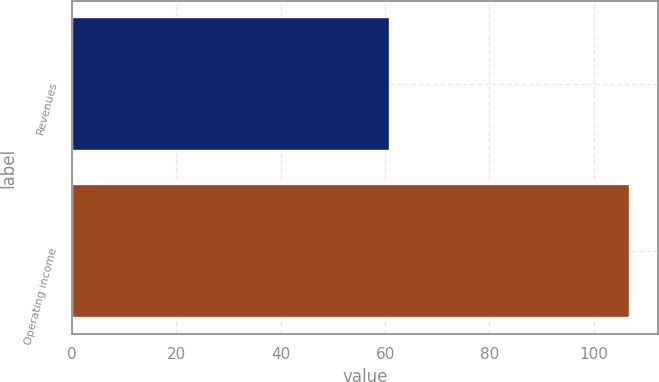Convert chart. <chart><loc_0><loc_0><loc_500><loc_500><bar_chart><fcel>Revenues<fcel>Operating income<nl><fcel>61<fcel>107<nl></chart> 